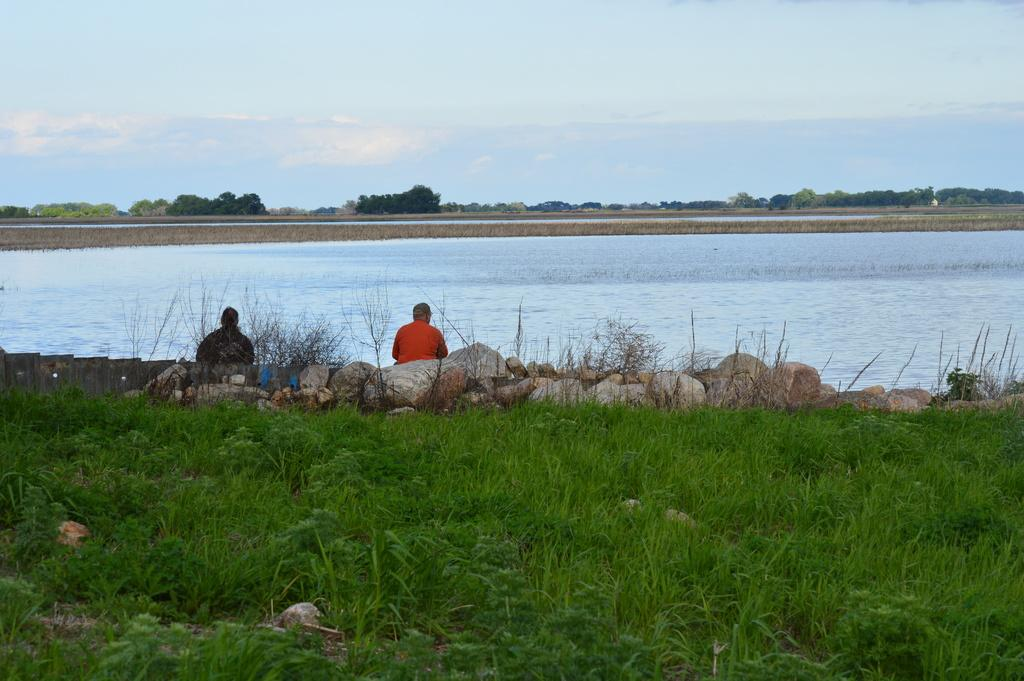What type of surface is on the ground in the image? There is grass on the ground in the image. What other objects can be seen on the ground? There are rocks in the image. How many people are sitting in the image? There are two persons sitting in the image. What can be seen in the background of the image? Water, ground, trees, and the sky are visible in the background of the image. What type of tray is being used by the dad in the image? There is no dad or tray present in the image. Can you tell me how many boats are visible in the image? There are no boats visible in the image. 